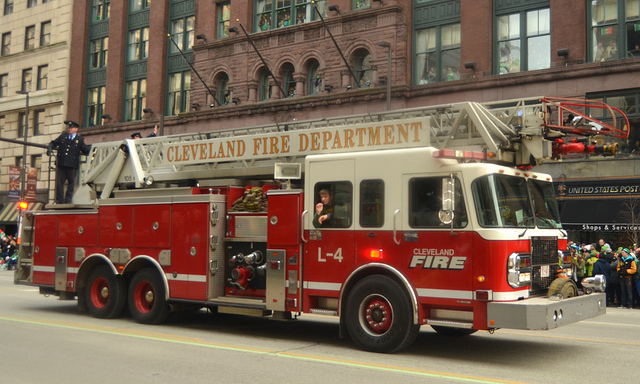Please extract the text content from this image. CLEVELAND FIRE DEPARTMENT L-4 CLEVELAND FIRE UNITED STATES MOST sHAPE 